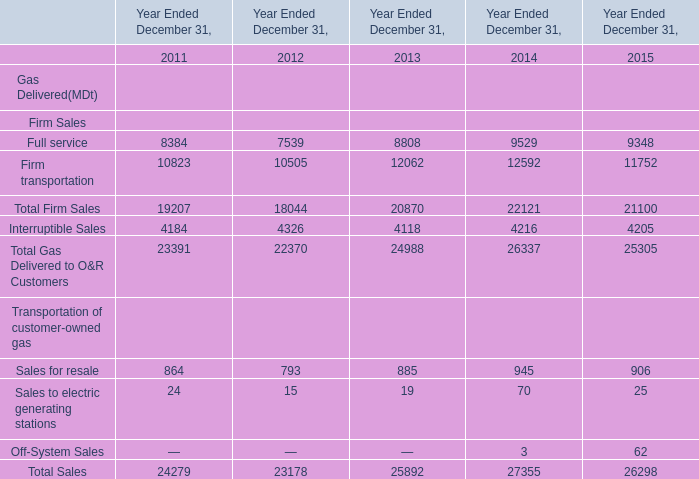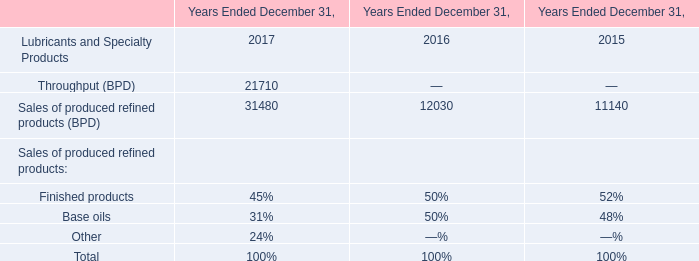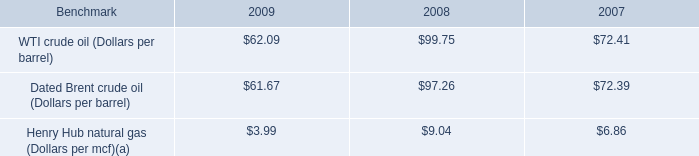Which year is Total Firm Sales greater than 22000 ? 
Answer: 2014. 